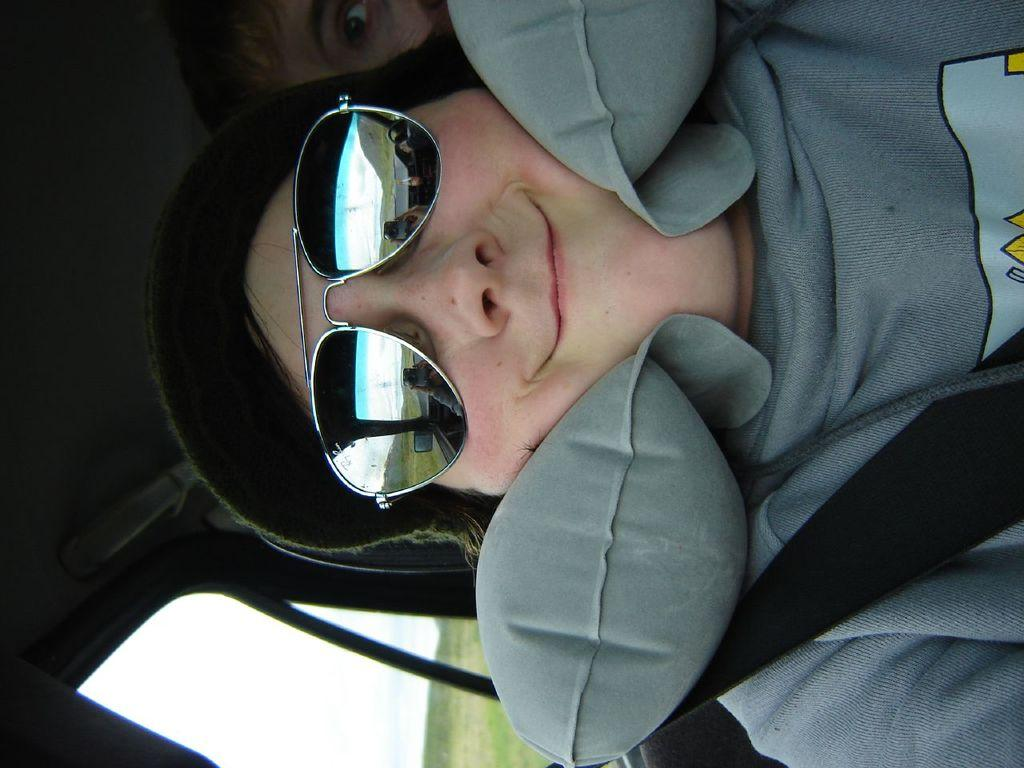What is the man in the image doing? The man is sitting in a car. Can you describe the man's appearance? The man is wearing glasses and a hat. Are there any other people visible in the image? Yes, there is another man in the background of the image. What type of request is the man playing the guitar making in the image? There is no guitar present in the image, and the man is not making any requests. 